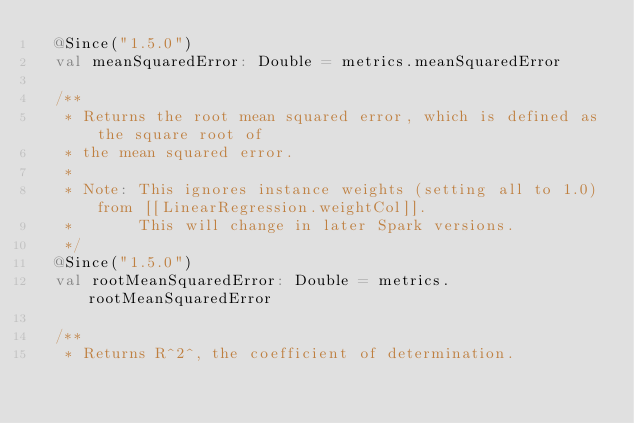<code> <loc_0><loc_0><loc_500><loc_500><_Scala_>  @Since("1.5.0")
  val meanSquaredError: Double = metrics.meanSquaredError

  /**
   * Returns the root mean squared error, which is defined as the square root of
   * the mean squared error.
   *
   * Note: This ignores instance weights (setting all to 1.0) from [[LinearRegression.weightCol]].
   *       This will change in later Spark versions.
   */
  @Since("1.5.0")
  val rootMeanSquaredError: Double = metrics.rootMeanSquaredError

  /**
   * Returns R^2^, the coefficient of determination.</code> 